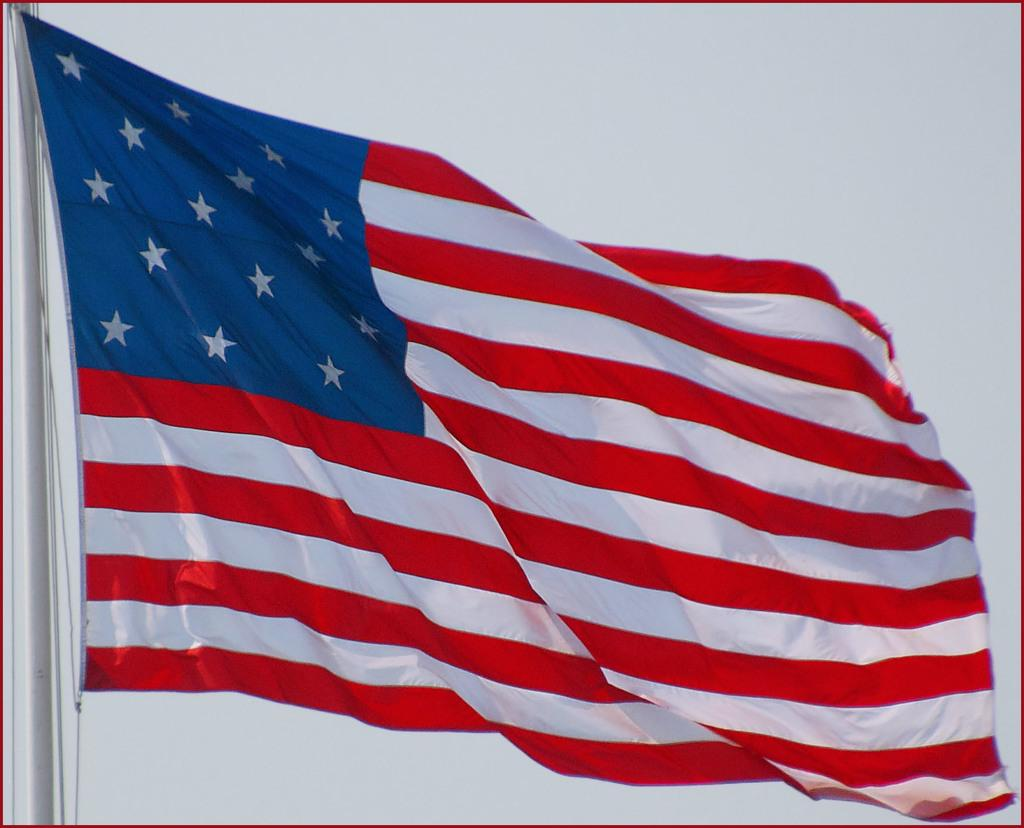What is the main subject in the center of the image? There is a flag in the center of the image. What can be seen in the background of the image? There is sky visible in the background of the image. Where is the pole located in the image? There is a pole on the left side of the image. What type of cork can be seen at the bottom of the flagpole in the image? There is no cork present at the bottom of the flagpole in the image. 